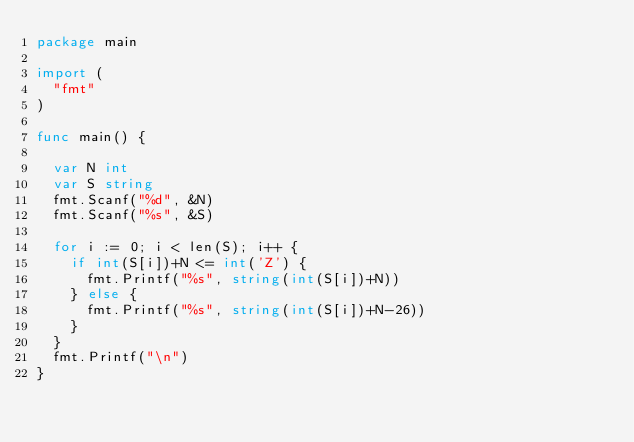Convert code to text. <code><loc_0><loc_0><loc_500><loc_500><_Go_>package main

import (
	"fmt"
)

func main() {

	var N int
	var S string
	fmt.Scanf("%d", &N)
	fmt.Scanf("%s", &S)

	for i := 0; i < len(S); i++ {
		if int(S[i])+N <= int('Z') {
			fmt.Printf("%s", string(int(S[i])+N))
		} else {
			fmt.Printf("%s", string(int(S[i])+N-26))
		}
	}
	fmt.Printf("\n")
}
</code> 